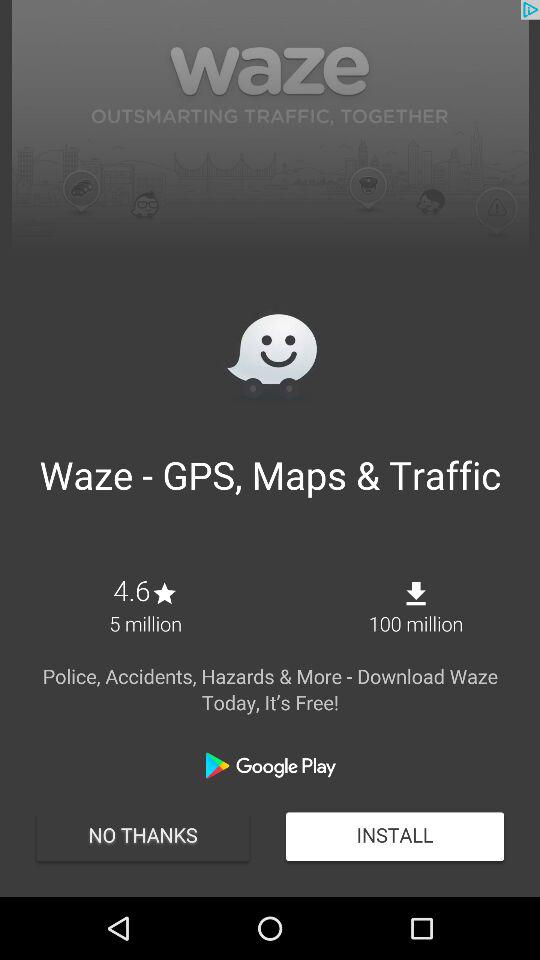How many more users have downloaded Waze than given it a rating?
Answer the question using a single word or phrase. 95 million 